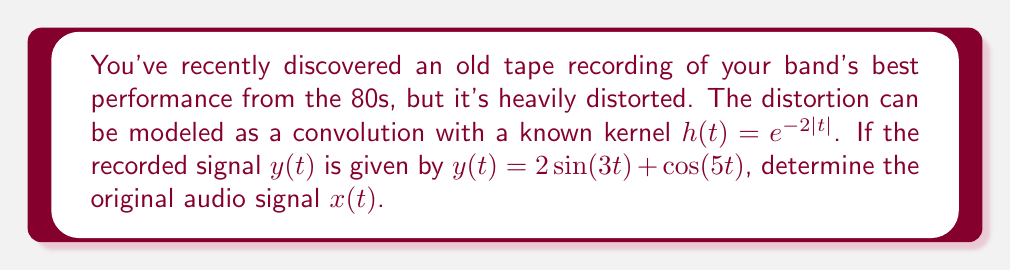What is the answer to this math problem? To solve this inverse problem, we'll follow these steps:

1) The recorded signal $y(t)$ is the result of convolving the original signal $x(t)$ with the distortion kernel $h(t)$:

   $y(t) = (x * h)(t)$

2) In the frequency domain, convolution becomes multiplication:

   $Y(\omega) = X(\omega)H(\omega)$

3) The Fourier transform of $h(t) = e^{-2|t|}$ is:

   $H(\omega) = \frac{4}{4+\omega^2}$

4) The Fourier transform of $y(t) = 2\sin(3t) + \cos(5t)$ is:

   $Y(\omega) = i\pi[\delta(\omega+3) - \delta(\omega-3)] + \frac{\pi}{2}[\delta(\omega+5) + \delta(\omega-5)]$

5) To find $X(\omega)$, we divide $Y(\omega)$ by $H(\omega)$:

   $X(\omega) = \frac{Y(\omega)}{H(\omega)} = \frac{i\pi[\delta(\omega+3) - \delta(\omega-3)] + \frac{\pi}{2}[\delta(\omega+5) + \delta(\omega-5)]}{\frac{4}{4+\omega^2}}$

6) Evaluating at the relevant frequencies:

   At $\omega = \pm 3$: $X(\pm 3) = \pm i\pi \cdot \frac{13}{4}$
   At $\omega = \pm 5$: $X(\pm 5) = \frac{\pi}{2} \cdot \frac{29}{4}$

7) The inverse Fourier transform gives us the original signal:

   $x(t) = \frac{13}{2}\sin(3t) + \frac{29}{8}\cos(5t)$
Answer: $x(t) = \frac{13}{2}\sin(3t) + \frac{29}{8}\cos(5t)$ 